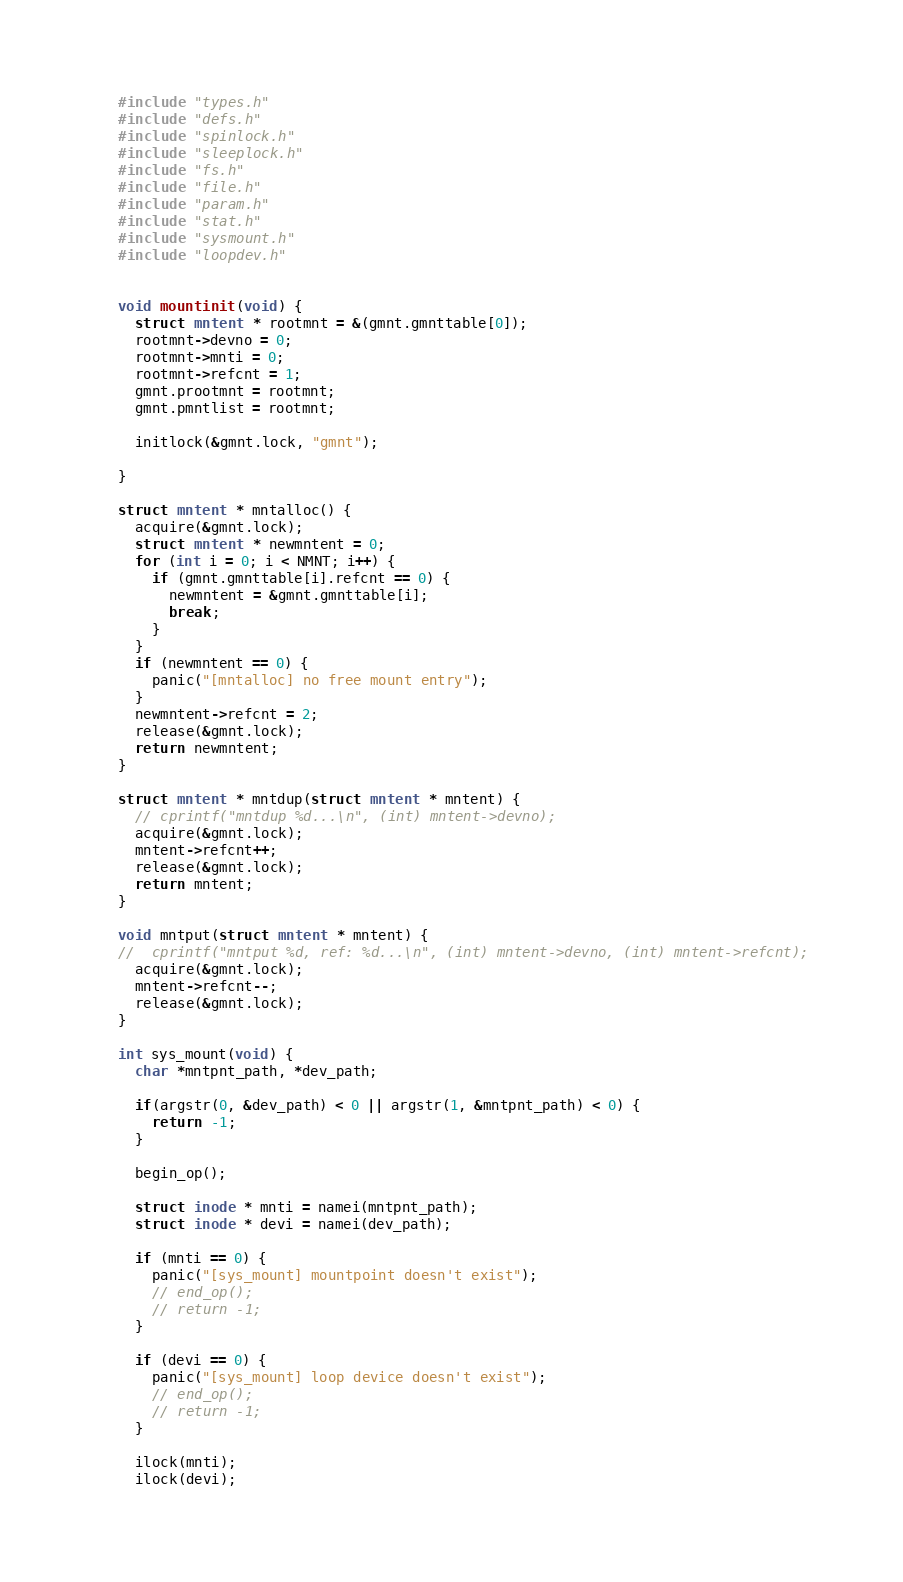Convert code to text. <code><loc_0><loc_0><loc_500><loc_500><_C_>#include "types.h"
#include "defs.h"
#include "spinlock.h"
#include "sleeplock.h"
#include "fs.h"
#include "file.h"
#include "param.h"
#include "stat.h"
#include "sysmount.h"
#include "loopdev.h"


void mountinit(void) {
  struct mntent * rootmnt = &(gmnt.gmnttable[0]);
  rootmnt->devno = 0;
  rootmnt->mnti = 0;
  rootmnt->refcnt = 1;
  gmnt.prootmnt = rootmnt;
  gmnt.pmntlist = rootmnt;

  initlock(&gmnt.lock, "gmnt");

}

struct mntent * mntalloc() {
  acquire(&gmnt.lock);
  struct mntent * newmntent = 0;
  for (int i = 0; i < NMNT; i++) {
    if (gmnt.gmnttable[i].refcnt == 0) {
      newmntent = &gmnt.gmnttable[i];
      break;
    }
  }
  if (newmntent == 0) {
    panic("[mntalloc] no free mount entry");
  }
  newmntent->refcnt = 2;
  release(&gmnt.lock);
  return newmntent;
}

struct mntent * mntdup(struct mntent * mntent) {
  // cprintf("mntdup %d...\n", (int) mntent->devno);
  acquire(&gmnt.lock);
  mntent->refcnt++;
  release(&gmnt.lock);
  return mntent;
}

void mntput(struct mntent * mntent) {
//  cprintf("mntput %d, ref: %d...\n", (int) mntent->devno, (int) mntent->refcnt);
  acquire(&gmnt.lock);
  mntent->refcnt--;
  release(&gmnt.lock);
}

int sys_mount(void) {
  char *mntpnt_path, *dev_path;

  if(argstr(0, &dev_path) < 0 || argstr(1, &mntpnt_path) < 0) {
    return -1;
  }

  begin_op();

  struct inode * mnti = namei(mntpnt_path);
  struct inode * devi = namei(dev_path);

  if (mnti == 0) {
    panic("[sys_mount] mountpoint doesn't exist");
    // end_op();
    // return -1;
  }

  if (devi == 0) {
    panic("[sys_mount] loop device doesn't exist");
    // end_op();
    // return -1;
  }

  ilock(mnti);
  ilock(devi);
</code> 